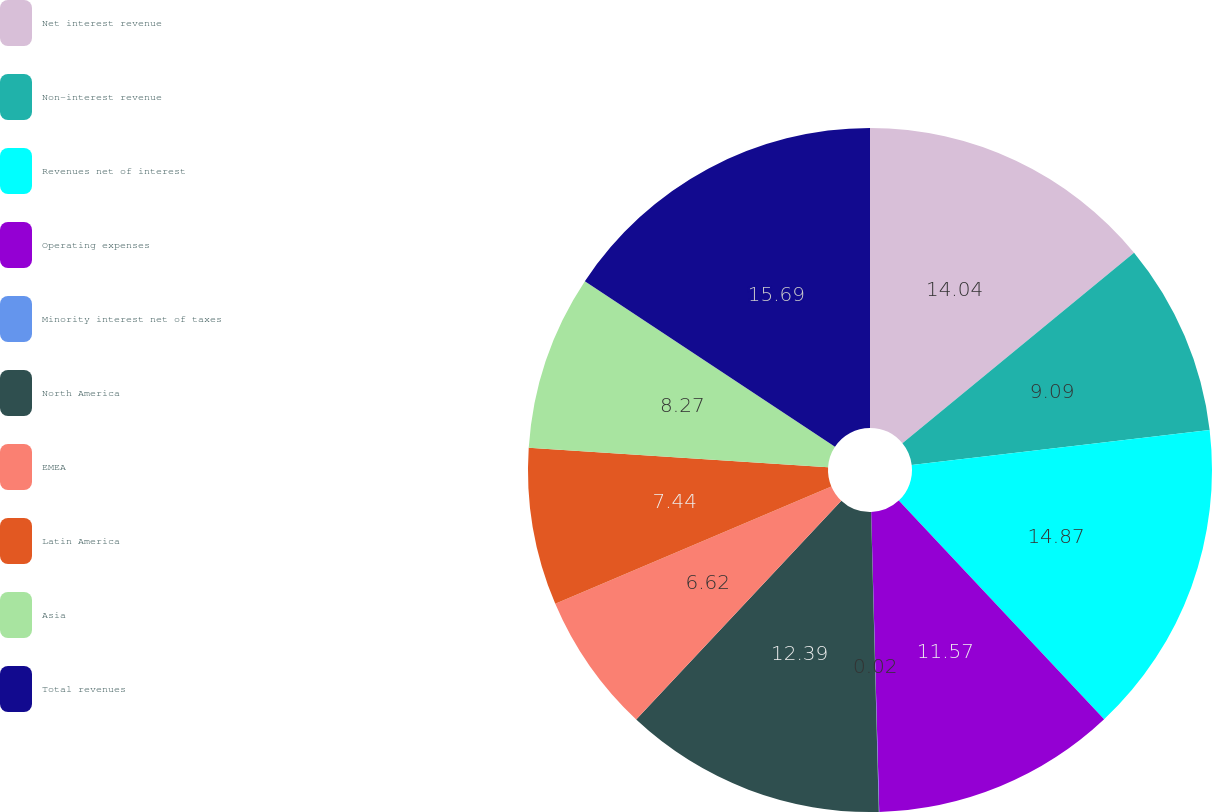<chart> <loc_0><loc_0><loc_500><loc_500><pie_chart><fcel>Net interest revenue<fcel>Non-interest revenue<fcel>Revenues net of interest<fcel>Operating expenses<fcel>Minority interest net of taxes<fcel>North America<fcel>EMEA<fcel>Latin America<fcel>Asia<fcel>Total revenues<nl><fcel>14.04%<fcel>9.09%<fcel>14.87%<fcel>11.57%<fcel>0.02%<fcel>12.39%<fcel>6.62%<fcel>7.44%<fcel>8.27%<fcel>15.69%<nl></chart> 